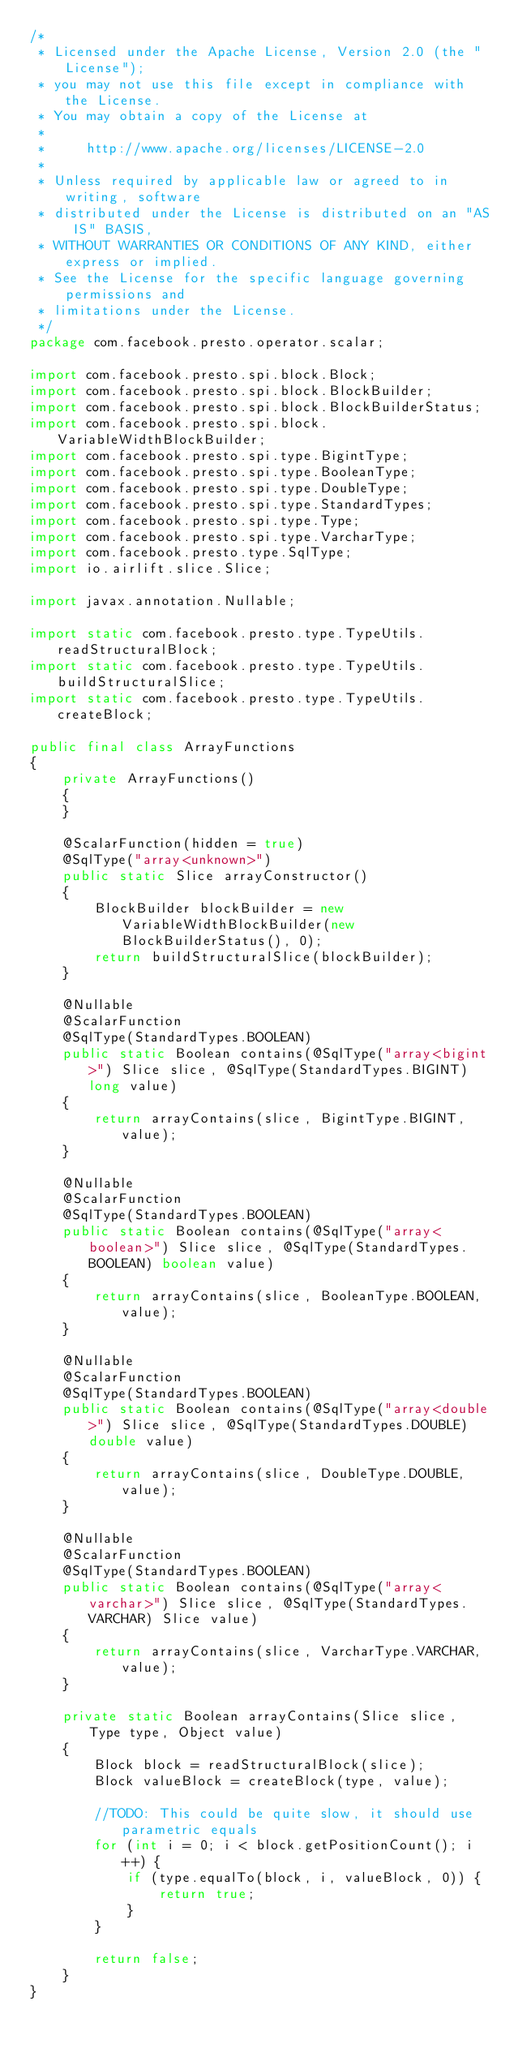Convert code to text. <code><loc_0><loc_0><loc_500><loc_500><_Java_>/*
 * Licensed under the Apache License, Version 2.0 (the "License");
 * you may not use this file except in compliance with the License.
 * You may obtain a copy of the License at
 *
 *     http://www.apache.org/licenses/LICENSE-2.0
 *
 * Unless required by applicable law or agreed to in writing, software
 * distributed under the License is distributed on an "AS IS" BASIS,
 * WITHOUT WARRANTIES OR CONDITIONS OF ANY KIND, either express or implied.
 * See the License for the specific language governing permissions and
 * limitations under the License.
 */
package com.facebook.presto.operator.scalar;

import com.facebook.presto.spi.block.Block;
import com.facebook.presto.spi.block.BlockBuilder;
import com.facebook.presto.spi.block.BlockBuilderStatus;
import com.facebook.presto.spi.block.VariableWidthBlockBuilder;
import com.facebook.presto.spi.type.BigintType;
import com.facebook.presto.spi.type.BooleanType;
import com.facebook.presto.spi.type.DoubleType;
import com.facebook.presto.spi.type.StandardTypes;
import com.facebook.presto.spi.type.Type;
import com.facebook.presto.spi.type.VarcharType;
import com.facebook.presto.type.SqlType;
import io.airlift.slice.Slice;

import javax.annotation.Nullable;

import static com.facebook.presto.type.TypeUtils.readStructuralBlock;
import static com.facebook.presto.type.TypeUtils.buildStructuralSlice;
import static com.facebook.presto.type.TypeUtils.createBlock;

public final class ArrayFunctions
{
    private ArrayFunctions()
    {
    }

    @ScalarFunction(hidden = true)
    @SqlType("array<unknown>")
    public static Slice arrayConstructor()
    {
        BlockBuilder blockBuilder = new VariableWidthBlockBuilder(new BlockBuilderStatus(), 0);
        return buildStructuralSlice(blockBuilder);
    }

    @Nullable
    @ScalarFunction
    @SqlType(StandardTypes.BOOLEAN)
    public static Boolean contains(@SqlType("array<bigint>") Slice slice, @SqlType(StandardTypes.BIGINT) long value)
    {
        return arrayContains(slice, BigintType.BIGINT, value);
    }

    @Nullable
    @ScalarFunction
    @SqlType(StandardTypes.BOOLEAN)
    public static Boolean contains(@SqlType("array<boolean>") Slice slice, @SqlType(StandardTypes.BOOLEAN) boolean value)
    {
        return arrayContains(slice, BooleanType.BOOLEAN, value);
    }

    @Nullable
    @ScalarFunction
    @SqlType(StandardTypes.BOOLEAN)
    public static Boolean contains(@SqlType("array<double>") Slice slice, @SqlType(StandardTypes.DOUBLE) double value)
    {
        return arrayContains(slice, DoubleType.DOUBLE, value);
    }

    @Nullable
    @ScalarFunction
    @SqlType(StandardTypes.BOOLEAN)
    public static Boolean contains(@SqlType("array<varchar>") Slice slice, @SqlType(StandardTypes.VARCHAR) Slice value)
    {
        return arrayContains(slice, VarcharType.VARCHAR, value);
    }

    private static Boolean arrayContains(Slice slice, Type type, Object value)
    {
        Block block = readStructuralBlock(slice);
        Block valueBlock = createBlock(type, value);

        //TODO: This could be quite slow, it should use parametric equals
        for (int i = 0; i < block.getPositionCount(); i++) {
            if (type.equalTo(block, i, valueBlock, 0)) {
                return true;
            }
        }

        return false;
    }
}
</code> 